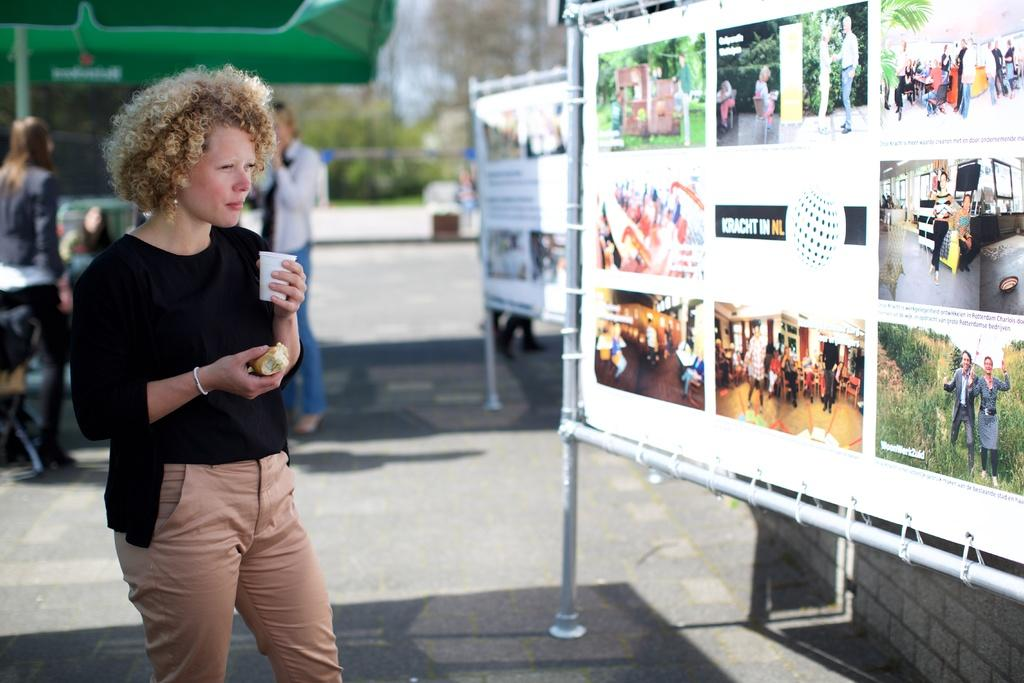What is the person in the image holding? The person is holding a glass and a food item. What can be seen on the walls in the image? There are posters in the image. What is visible in the background of the image? In the background, there is a group of people, an umbrella, plants, trees, and the sky. Where is the flower located in the image? There is no flower present in the image. What type of rest can be seen in the image? The image does not depict any form of rest or relaxation. 